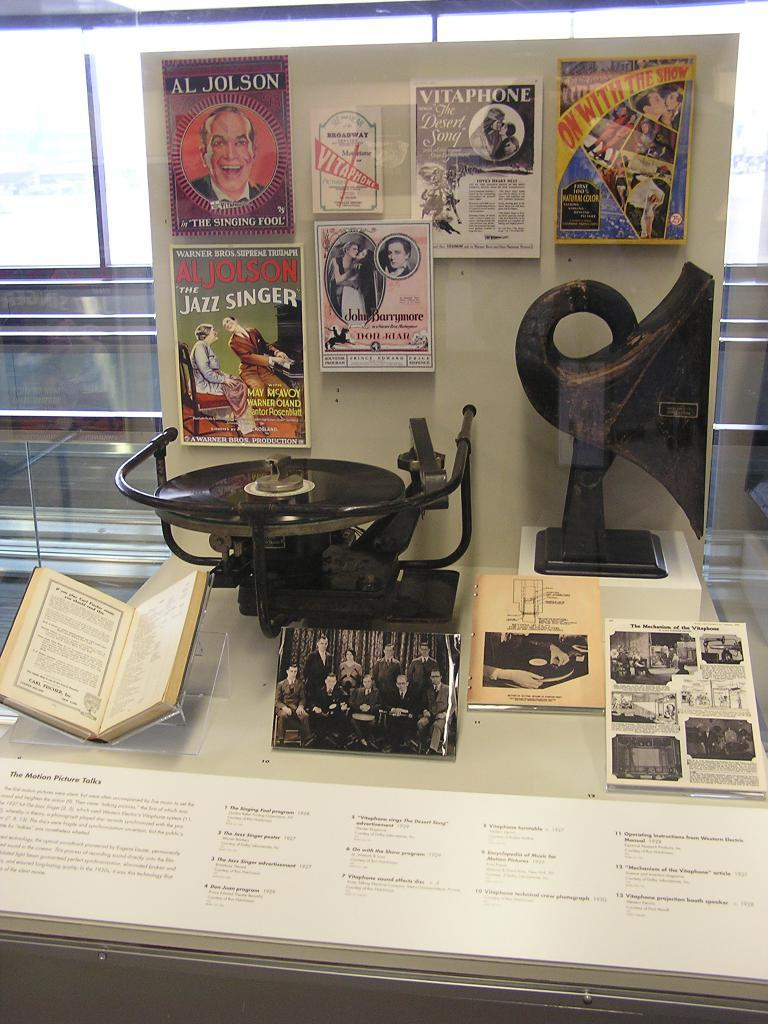Provide a one-sentence caption for the provided image. A display case labeled "the motion picture talks" shows an old record player with various magazines. 